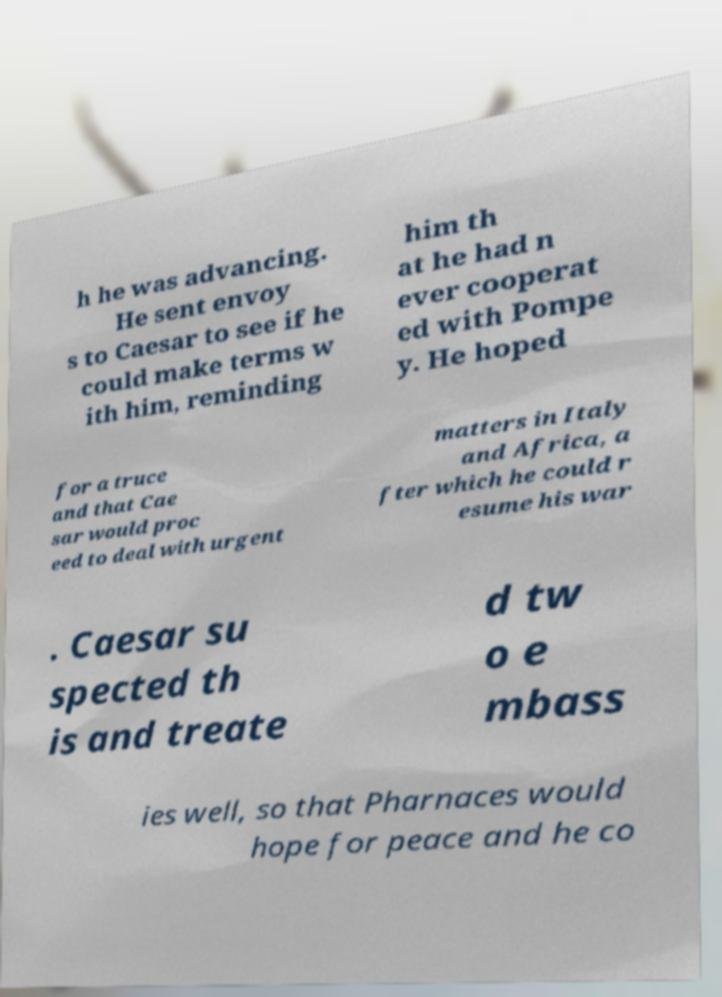Please read and relay the text visible in this image. What does it say? h he was advancing. He sent envoy s to Caesar to see if he could make terms w ith him, reminding him th at he had n ever cooperat ed with Pompe y. He hoped for a truce and that Cae sar would proc eed to deal with urgent matters in Italy and Africa, a fter which he could r esume his war . Caesar su spected th is and treate d tw o e mbass ies well, so that Pharnaces would hope for peace and he co 